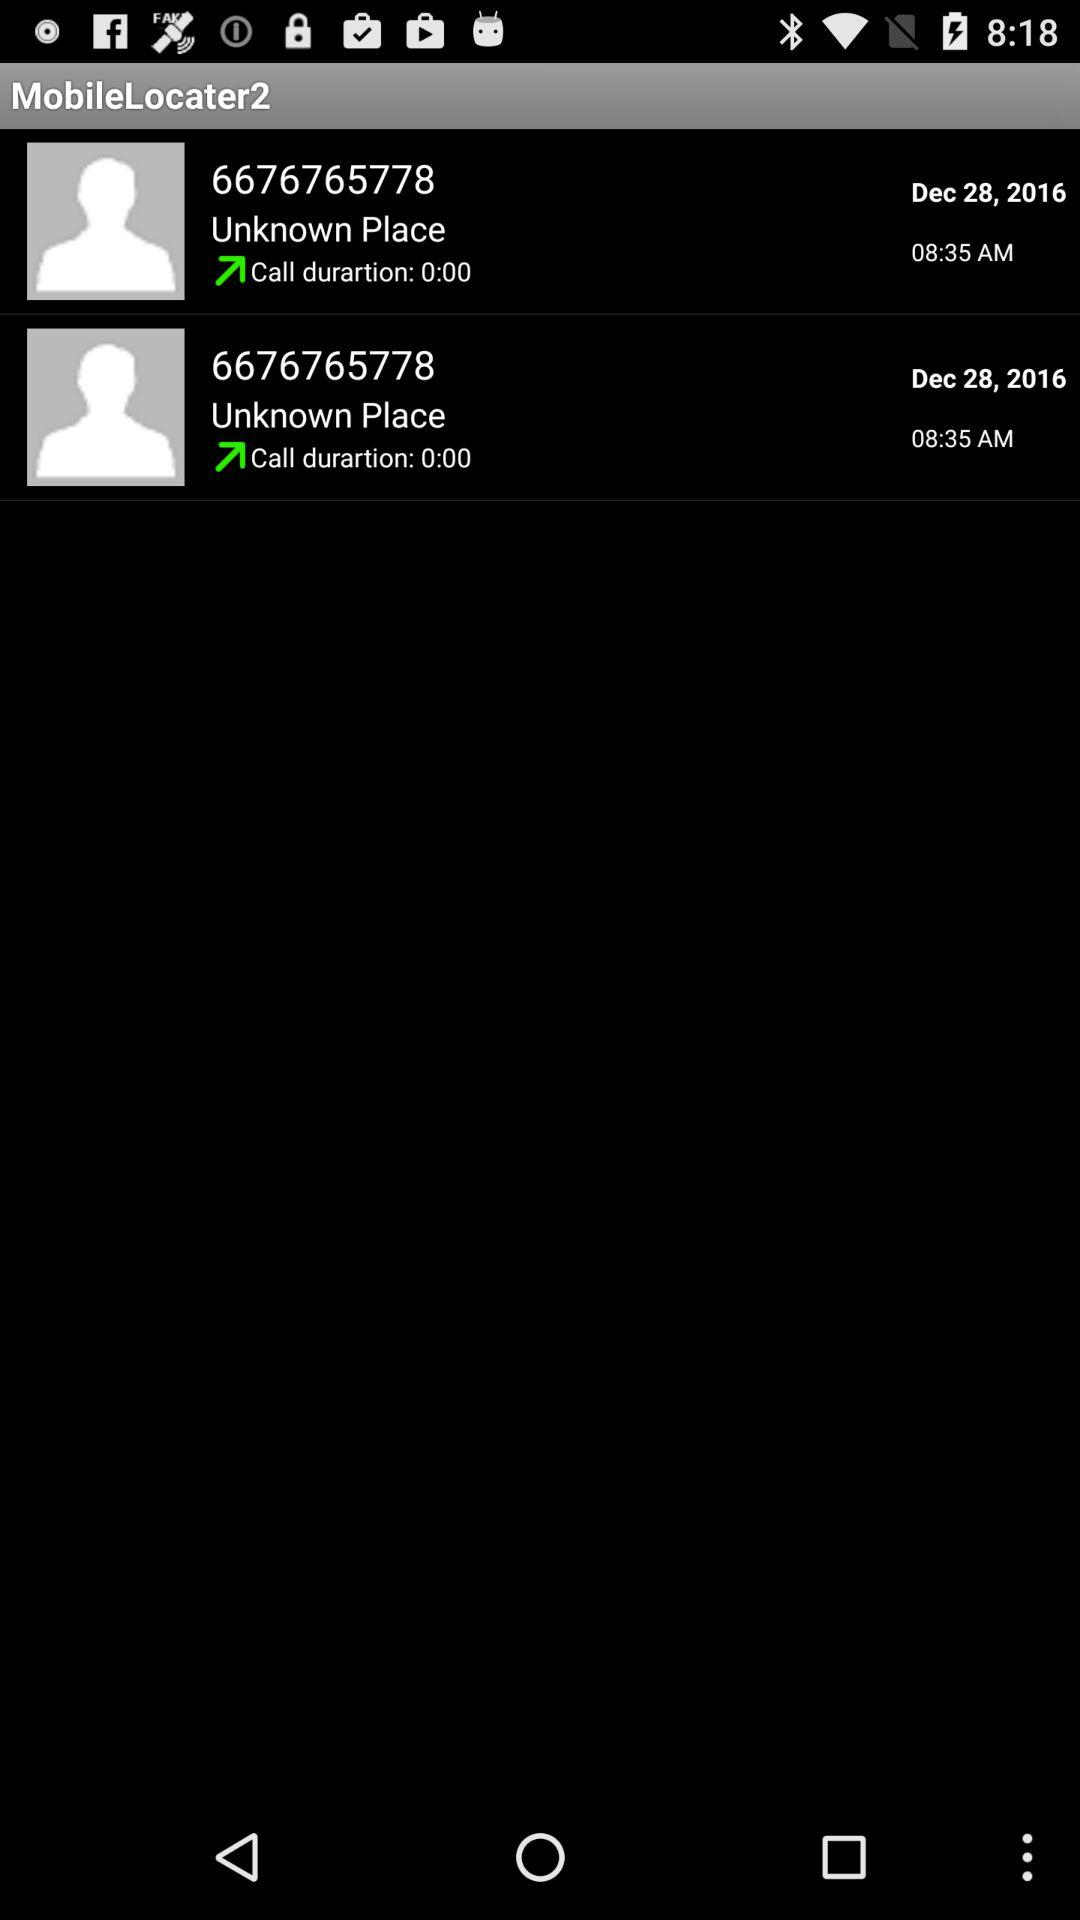What is the duration of the call with 6676765778? The duration of the call is 0 seconds. 